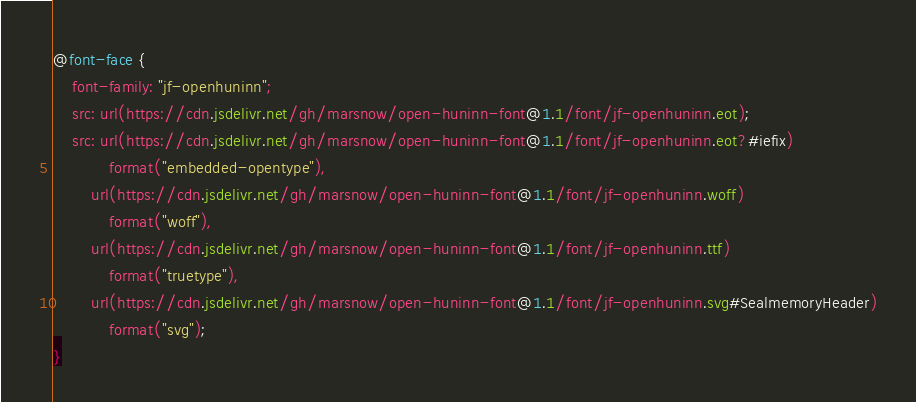<code> <loc_0><loc_0><loc_500><loc_500><_CSS_>@font-face {
    font-family: "jf-openhuninn";
    src: url(https://cdn.jsdelivr.net/gh/marsnow/open-huninn-font@1.1/font/jf-openhuninn.eot);
    src: url(https://cdn.jsdelivr.net/gh/marsnow/open-huninn-font@1.1/font/jf-openhuninn.eot?#iefix)
            format("embedded-opentype"),
        url(https://cdn.jsdelivr.net/gh/marsnow/open-huninn-font@1.1/font/jf-openhuninn.woff)
            format("woff"),
        url(https://cdn.jsdelivr.net/gh/marsnow/open-huninn-font@1.1/font/jf-openhuninn.ttf)
            format("truetype"),
        url(https://cdn.jsdelivr.net/gh/marsnow/open-huninn-font@1.1/font/jf-openhuninn.svg#SealmemoryHeader)
            format("svg");
}
</code> 